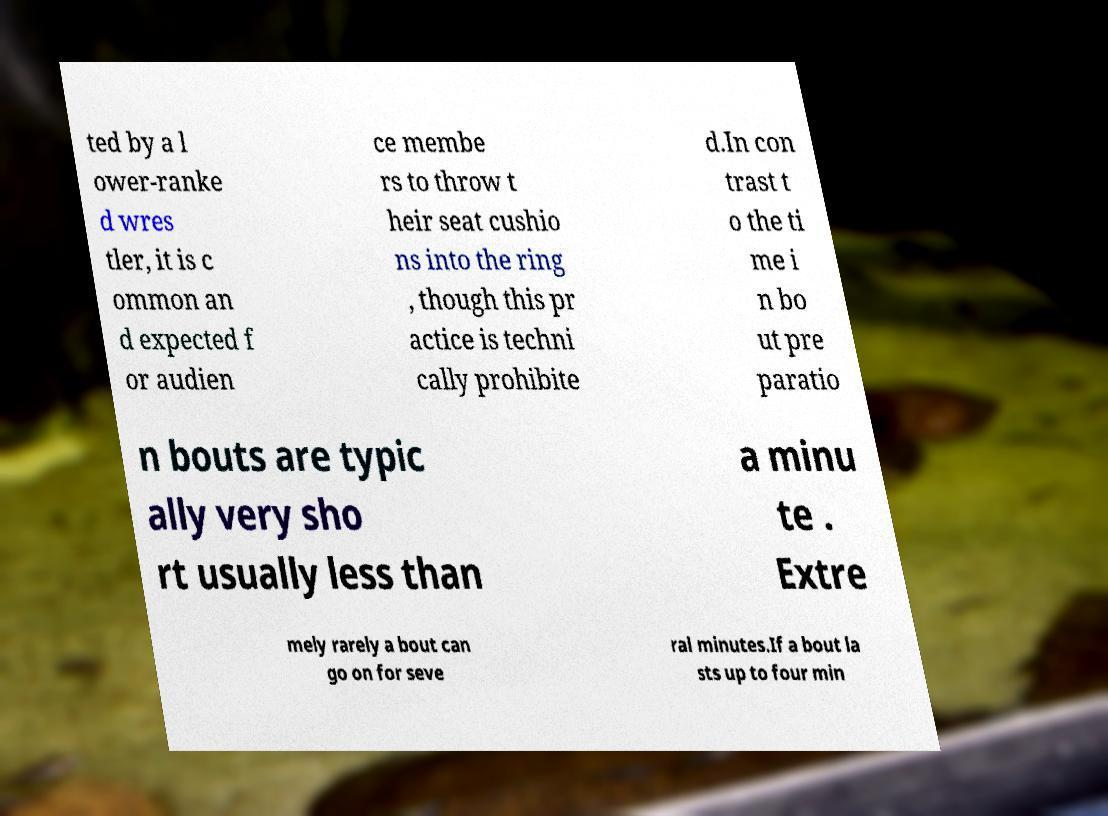Please identify and transcribe the text found in this image. ted by a l ower-ranke d wres tler, it is c ommon an d expected f or audien ce membe rs to throw t heir seat cushio ns into the ring , though this pr actice is techni cally prohibite d.In con trast t o the ti me i n bo ut pre paratio n bouts are typic ally very sho rt usually less than a minu te . Extre mely rarely a bout can go on for seve ral minutes.If a bout la sts up to four min 